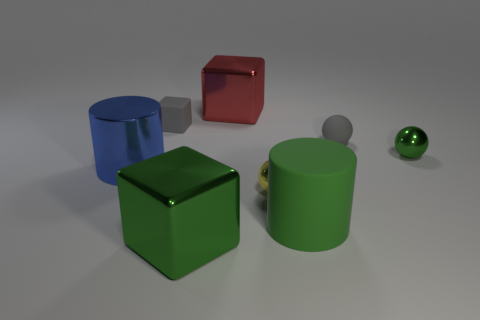There is a blue object that is the same size as the red metallic object; what shape is it?
Give a very brief answer. Cylinder. Are there any tiny red rubber things of the same shape as the red metal object?
Make the answer very short. No. Is the shape of the rubber thing that is in front of the yellow metallic object the same as the green thing to the right of the large green cylinder?
Offer a very short reply. No. What is the material of the cube that is the same size as the yellow metallic object?
Ensure brevity in your answer.  Rubber. What number of other objects are there of the same material as the tiny cube?
Your response must be concise. 2. There is a small object left of the big shiny cube behind the small rubber ball; what is its shape?
Give a very brief answer. Cube. How many objects are yellow rubber blocks or small yellow things on the left side of the large matte thing?
Keep it short and to the point. 1. What number of other objects are there of the same color as the metal cylinder?
Your answer should be compact. 0. What number of green things are either small shiny objects or big matte cylinders?
Make the answer very short. 2. Are there any large blocks that are in front of the tiny gray matte thing that is behind the gray rubber object on the right side of the rubber block?
Your answer should be very brief. Yes. 